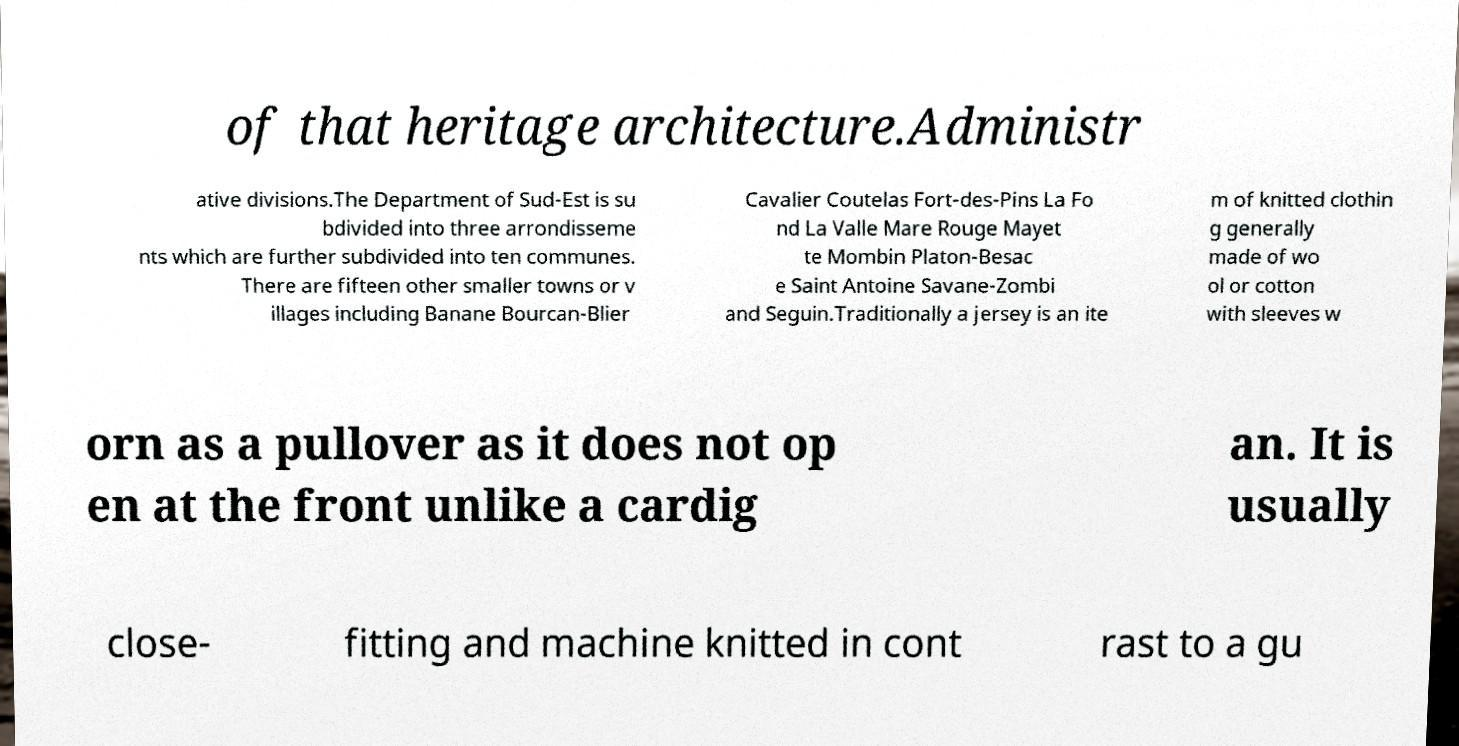Could you assist in decoding the text presented in this image and type it out clearly? of that heritage architecture.Administr ative divisions.The Department of Sud-Est is su bdivided into three arrondisseme nts which are further subdivided into ten communes. There are fifteen other smaller towns or v illages including Banane Bourcan-Blier Cavalier Coutelas Fort-des-Pins La Fo nd La Valle Mare Rouge Mayet te Mombin Platon-Besac e Saint Antoine Savane-Zombi and Seguin.Traditionally a jersey is an ite m of knitted clothin g generally made of wo ol or cotton with sleeves w orn as a pullover as it does not op en at the front unlike a cardig an. It is usually close- fitting and machine knitted in cont rast to a gu 